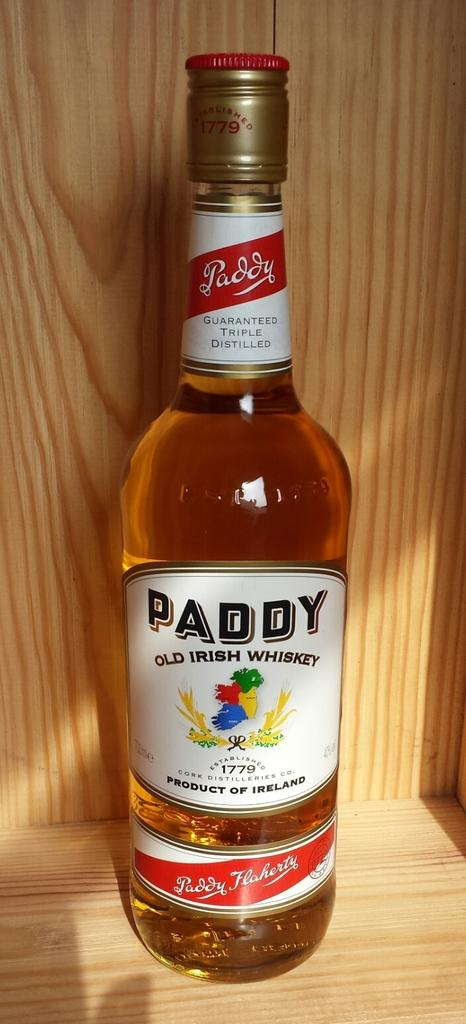<image>
Give a short and clear explanation of the subsequent image. A bottle of OLD IRISH WHISKEY from the PADDY brand. 